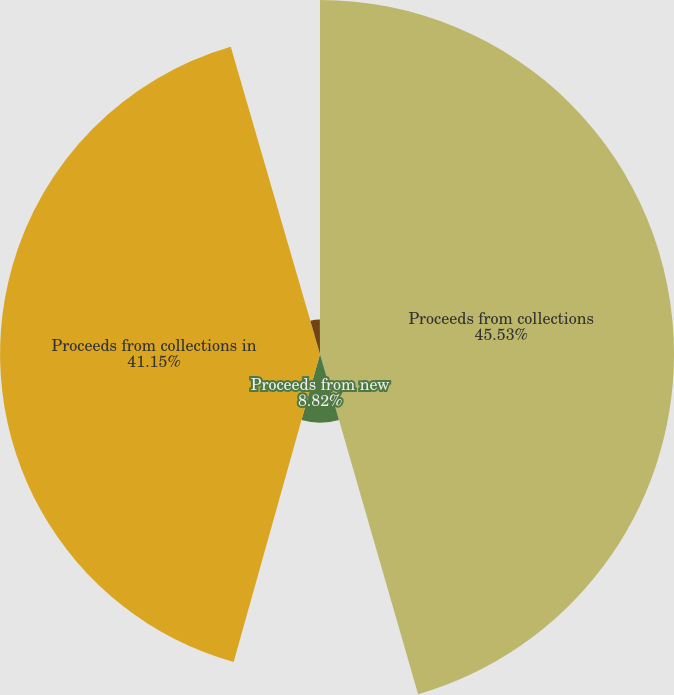Convert chart to OTSL. <chart><loc_0><loc_0><loc_500><loc_500><pie_chart><fcel>Proceeds from collections<fcel>Proceeds from new<fcel>Proceeds from collections in<fcel>Cash flows received on the<fcel>Cash flows received on<nl><fcel>45.53%<fcel>8.82%<fcel>41.15%<fcel>4.44%<fcel>0.06%<nl></chart> 